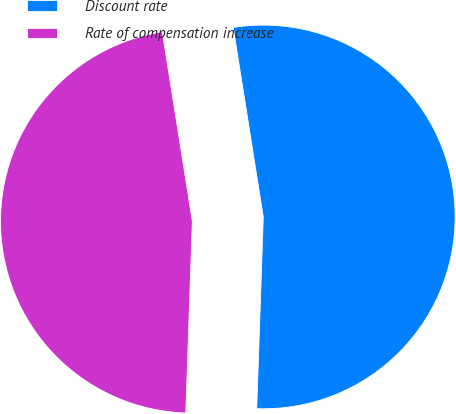Convert chart. <chart><loc_0><loc_0><loc_500><loc_500><pie_chart><fcel>Discount rate<fcel>Rate of compensation increase<nl><fcel>53.05%<fcel>46.95%<nl></chart> 